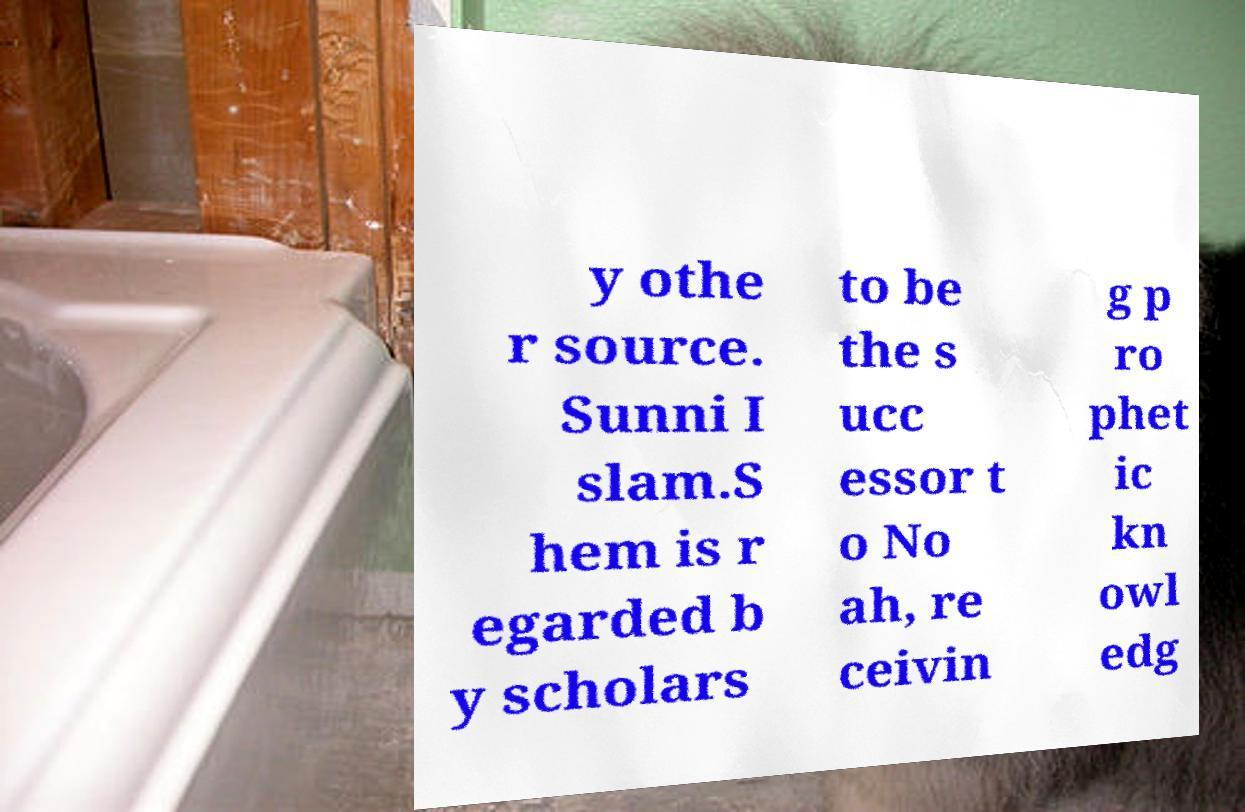Please read and relay the text visible in this image. What does it say? y othe r source. Sunni I slam.S hem is r egarded b y scholars to be the s ucc essor t o No ah, re ceivin g p ro phet ic kn owl edg 